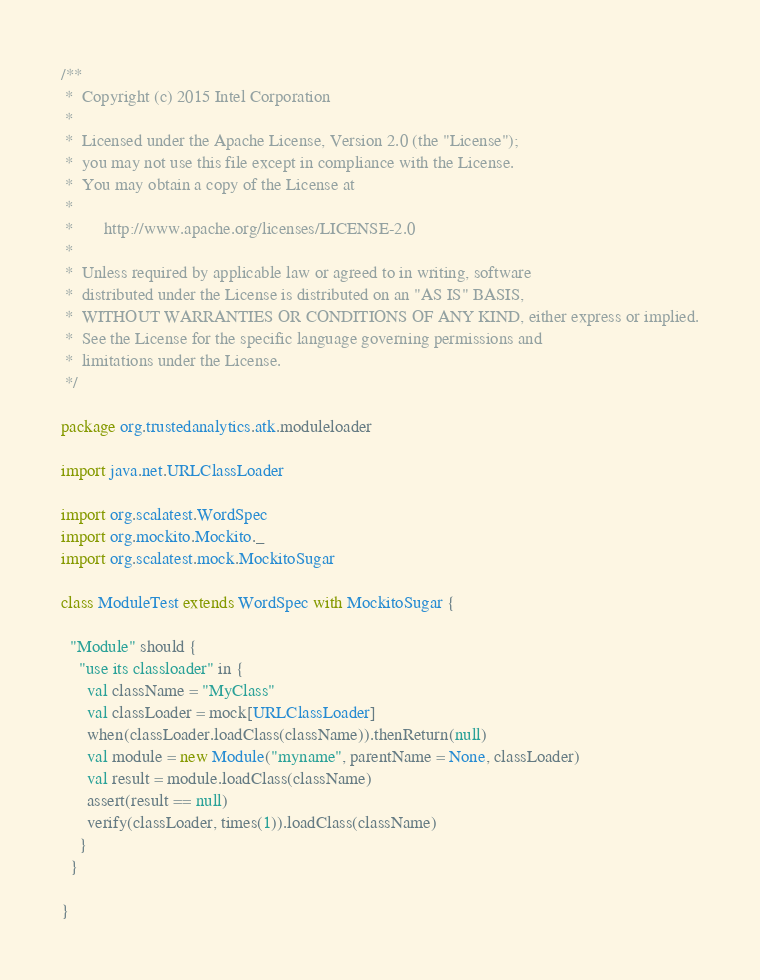<code> <loc_0><loc_0><loc_500><loc_500><_Scala_>/**
 *  Copyright (c) 2015 Intel Corporation 
 *
 *  Licensed under the Apache License, Version 2.0 (the "License");
 *  you may not use this file except in compliance with the License.
 *  You may obtain a copy of the License at
 *
 *       http://www.apache.org/licenses/LICENSE-2.0
 *
 *  Unless required by applicable law or agreed to in writing, software
 *  distributed under the License is distributed on an "AS IS" BASIS,
 *  WITHOUT WARRANTIES OR CONDITIONS OF ANY KIND, either express or implied.
 *  See the License for the specific language governing permissions and
 *  limitations under the License.
 */

package org.trustedanalytics.atk.moduleloader

import java.net.URLClassLoader

import org.scalatest.WordSpec
import org.mockito.Mockito._
import org.scalatest.mock.MockitoSugar

class ModuleTest extends WordSpec with MockitoSugar {

  "Module" should {
    "use its classloader" in {
      val className = "MyClass"
      val classLoader = mock[URLClassLoader]
      when(classLoader.loadClass(className)).thenReturn(null)
      val module = new Module("myname", parentName = None, classLoader)
      val result = module.loadClass(className)
      assert(result == null)
      verify(classLoader, times(1)).loadClass(className)
    }
  }

}
</code> 